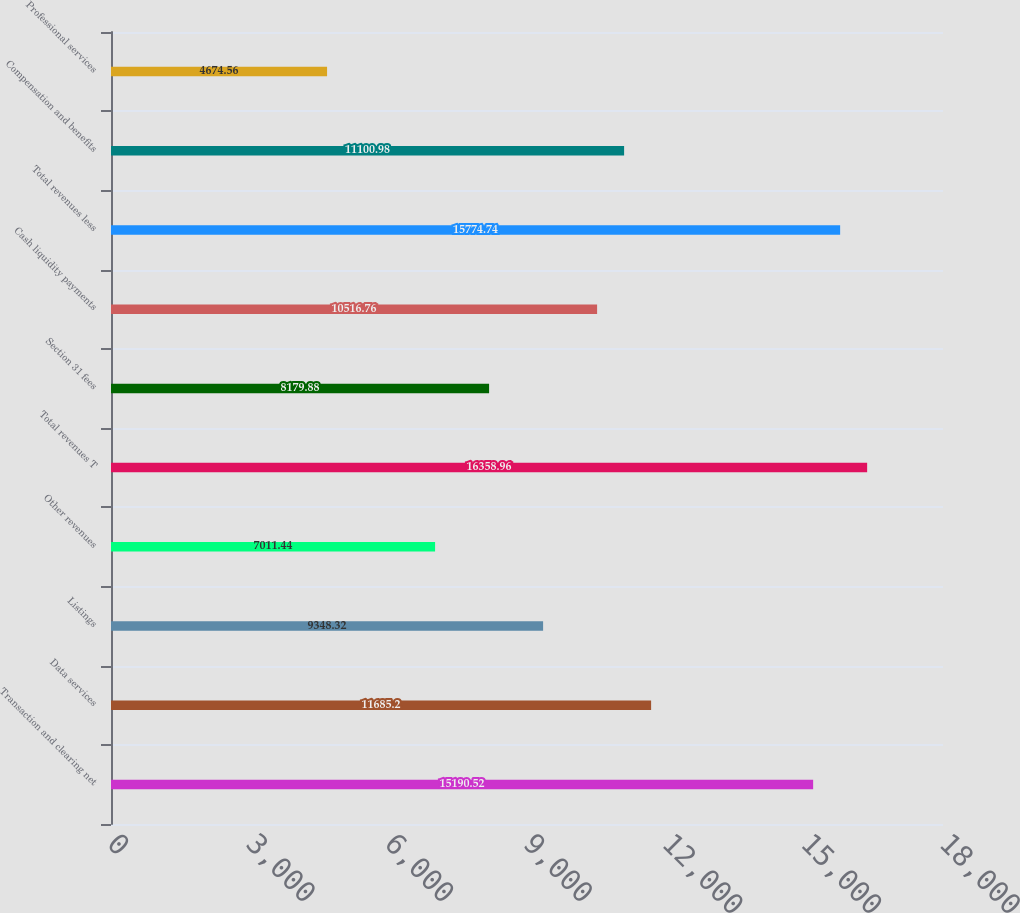<chart> <loc_0><loc_0><loc_500><loc_500><bar_chart><fcel>Transaction and clearing net<fcel>Data services<fcel>Listings<fcel>Other revenues<fcel>Total revenues T<fcel>Section 31 fees<fcel>Cash liquidity payments<fcel>Total revenues less<fcel>Compensation and benefits<fcel>Professional services<nl><fcel>15190.5<fcel>11685.2<fcel>9348.32<fcel>7011.44<fcel>16359<fcel>8179.88<fcel>10516.8<fcel>15774.7<fcel>11101<fcel>4674.56<nl></chart> 